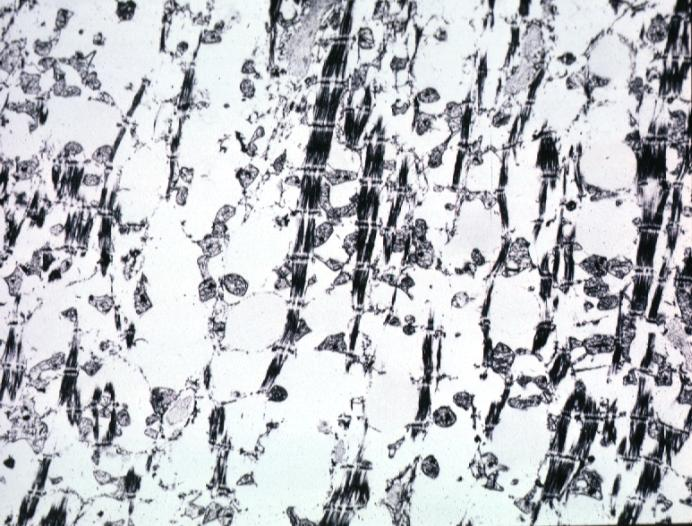s cardiovascular present?
Answer the question using a single word or phrase. Yes 